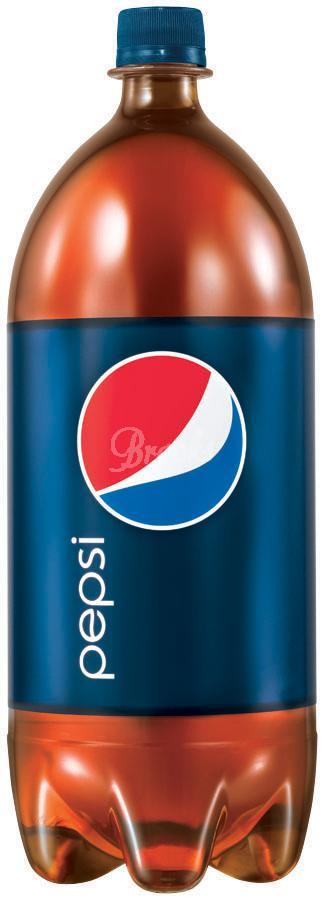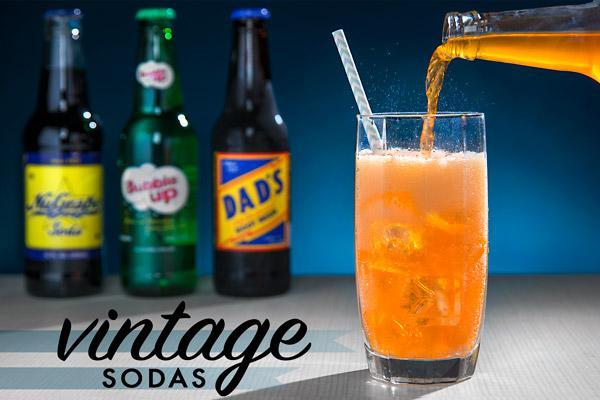The first image is the image on the left, the second image is the image on the right. Assess this claim about the two images: "There is a total of six bottles". Correct or not? Answer yes or no. No. The first image is the image on the left, the second image is the image on the right. Considering the images on both sides, is "There are the same number of bottles in each of the images." valid? Answer yes or no. No. 